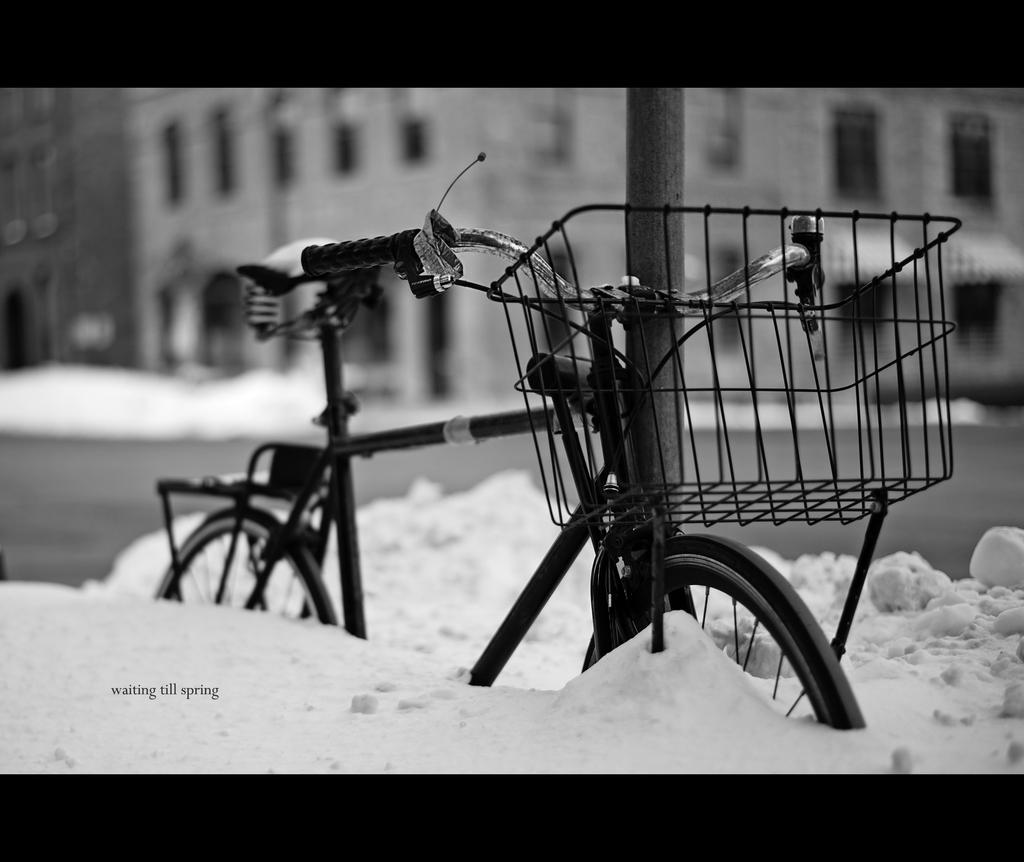What is the color scheme of the image? The image is black and white. What is the main subject in the center of the image? There is a bicycle and a pole in the center of the image. What can be seen in the background of the image? There are buildings, snow, and a road visible in the background of the image. What type of wood is used to construct the bicycle in the image? There is no wood visible in the image, and the bicycle is not constructed of wood. 